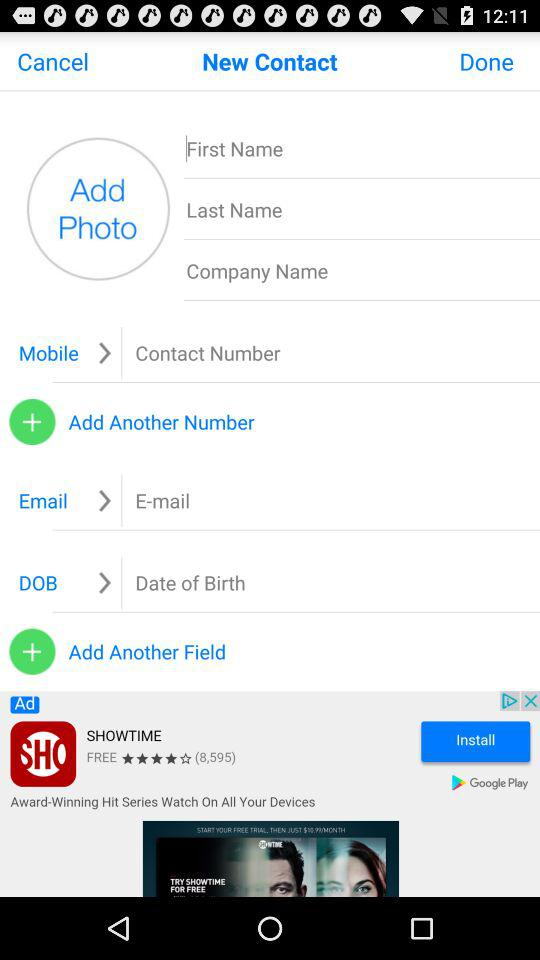Who is calling? The person who is calling is "app appy". 